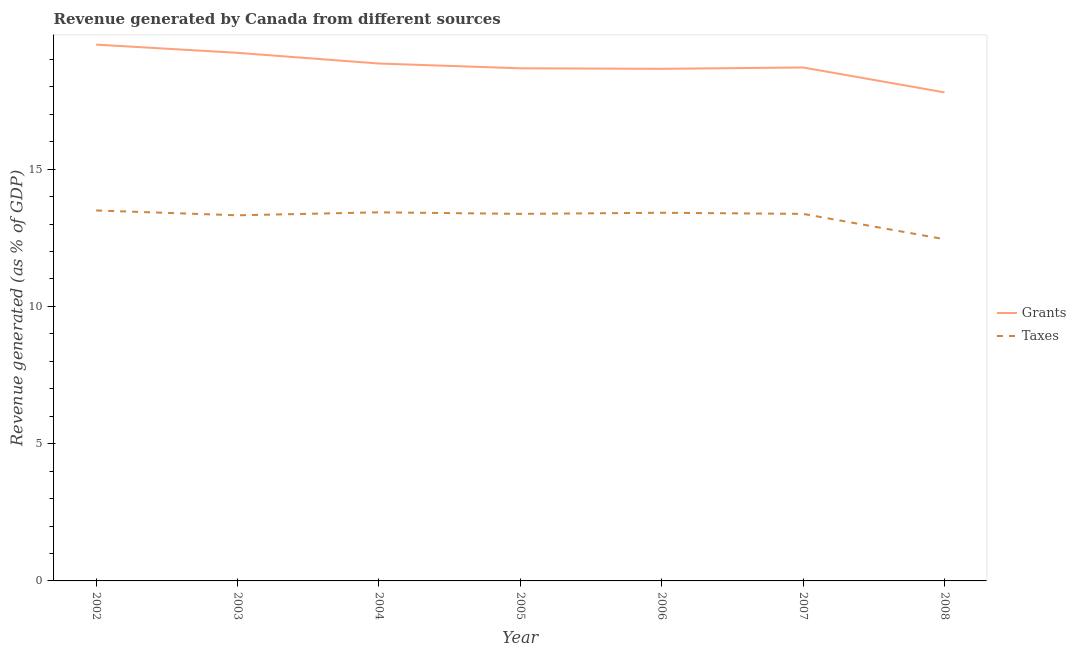Is the number of lines equal to the number of legend labels?
Keep it short and to the point. Yes. What is the revenue generated by grants in 2004?
Your answer should be very brief. 18.85. Across all years, what is the maximum revenue generated by taxes?
Provide a succinct answer. 13.49. Across all years, what is the minimum revenue generated by grants?
Make the answer very short. 17.79. What is the total revenue generated by taxes in the graph?
Your answer should be very brief. 92.83. What is the difference between the revenue generated by taxes in 2007 and that in 2008?
Ensure brevity in your answer.  0.92. What is the difference between the revenue generated by taxes in 2002 and the revenue generated by grants in 2007?
Provide a succinct answer. -5.21. What is the average revenue generated by taxes per year?
Your answer should be compact. 13.26. In the year 2008, what is the difference between the revenue generated by grants and revenue generated by taxes?
Ensure brevity in your answer.  5.35. What is the ratio of the revenue generated by grants in 2003 to that in 2007?
Provide a succinct answer. 1.03. What is the difference between the highest and the second highest revenue generated by taxes?
Make the answer very short. 0.07. What is the difference between the highest and the lowest revenue generated by grants?
Your response must be concise. 1.74. Is the sum of the revenue generated by grants in 2006 and 2007 greater than the maximum revenue generated by taxes across all years?
Provide a succinct answer. Yes. Is the revenue generated by grants strictly greater than the revenue generated by taxes over the years?
Provide a short and direct response. Yes. How many years are there in the graph?
Ensure brevity in your answer.  7. Does the graph contain grids?
Your response must be concise. No. Where does the legend appear in the graph?
Provide a succinct answer. Center right. How are the legend labels stacked?
Your answer should be very brief. Vertical. What is the title of the graph?
Your answer should be very brief. Revenue generated by Canada from different sources. Does "Underweight" appear as one of the legend labels in the graph?
Your answer should be compact. No. What is the label or title of the X-axis?
Ensure brevity in your answer.  Year. What is the label or title of the Y-axis?
Give a very brief answer. Revenue generated (as % of GDP). What is the Revenue generated (as % of GDP) of Grants in 2002?
Offer a terse response. 19.53. What is the Revenue generated (as % of GDP) in Taxes in 2002?
Provide a short and direct response. 13.49. What is the Revenue generated (as % of GDP) of Grants in 2003?
Offer a very short reply. 19.24. What is the Revenue generated (as % of GDP) in Taxes in 2003?
Give a very brief answer. 13.32. What is the Revenue generated (as % of GDP) of Grants in 2004?
Your answer should be compact. 18.85. What is the Revenue generated (as % of GDP) in Taxes in 2004?
Offer a terse response. 13.43. What is the Revenue generated (as % of GDP) in Grants in 2005?
Provide a succinct answer. 18.67. What is the Revenue generated (as % of GDP) in Taxes in 2005?
Make the answer very short. 13.37. What is the Revenue generated (as % of GDP) in Grants in 2006?
Your response must be concise. 18.65. What is the Revenue generated (as % of GDP) in Taxes in 2006?
Ensure brevity in your answer.  13.41. What is the Revenue generated (as % of GDP) in Grants in 2007?
Your answer should be compact. 18.7. What is the Revenue generated (as % of GDP) in Taxes in 2007?
Give a very brief answer. 13.37. What is the Revenue generated (as % of GDP) in Grants in 2008?
Offer a terse response. 17.79. What is the Revenue generated (as % of GDP) of Taxes in 2008?
Give a very brief answer. 12.45. Across all years, what is the maximum Revenue generated (as % of GDP) of Grants?
Keep it short and to the point. 19.53. Across all years, what is the maximum Revenue generated (as % of GDP) of Taxes?
Give a very brief answer. 13.49. Across all years, what is the minimum Revenue generated (as % of GDP) in Grants?
Provide a short and direct response. 17.79. Across all years, what is the minimum Revenue generated (as % of GDP) in Taxes?
Offer a terse response. 12.45. What is the total Revenue generated (as % of GDP) in Grants in the graph?
Your response must be concise. 131.43. What is the total Revenue generated (as % of GDP) in Taxes in the graph?
Offer a very short reply. 92.83. What is the difference between the Revenue generated (as % of GDP) in Grants in 2002 and that in 2003?
Give a very brief answer. 0.3. What is the difference between the Revenue generated (as % of GDP) of Taxes in 2002 and that in 2003?
Offer a very short reply. 0.18. What is the difference between the Revenue generated (as % of GDP) in Grants in 2002 and that in 2004?
Ensure brevity in your answer.  0.69. What is the difference between the Revenue generated (as % of GDP) in Taxes in 2002 and that in 2004?
Your answer should be compact. 0.07. What is the difference between the Revenue generated (as % of GDP) in Grants in 2002 and that in 2005?
Your answer should be compact. 0.86. What is the difference between the Revenue generated (as % of GDP) of Taxes in 2002 and that in 2005?
Give a very brief answer. 0.12. What is the difference between the Revenue generated (as % of GDP) in Grants in 2002 and that in 2006?
Offer a very short reply. 0.88. What is the difference between the Revenue generated (as % of GDP) of Taxes in 2002 and that in 2006?
Keep it short and to the point. 0.08. What is the difference between the Revenue generated (as % of GDP) of Grants in 2002 and that in 2007?
Give a very brief answer. 0.83. What is the difference between the Revenue generated (as % of GDP) in Taxes in 2002 and that in 2007?
Ensure brevity in your answer.  0.12. What is the difference between the Revenue generated (as % of GDP) of Grants in 2002 and that in 2008?
Offer a terse response. 1.74. What is the difference between the Revenue generated (as % of GDP) in Taxes in 2002 and that in 2008?
Provide a short and direct response. 1.05. What is the difference between the Revenue generated (as % of GDP) in Grants in 2003 and that in 2004?
Make the answer very short. 0.39. What is the difference between the Revenue generated (as % of GDP) of Taxes in 2003 and that in 2004?
Offer a very short reply. -0.11. What is the difference between the Revenue generated (as % of GDP) in Grants in 2003 and that in 2005?
Make the answer very short. 0.56. What is the difference between the Revenue generated (as % of GDP) of Taxes in 2003 and that in 2005?
Your response must be concise. -0.05. What is the difference between the Revenue generated (as % of GDP) of Grants in 2003 and that in 2006?
Give a very brief answer. 0.58. What is the difference between the Revenue generated (as % of GDP) in Taxes in 2003 and that in 2006?
Ensure brevity in your answer.  -0.09. What is the difference between the Revenue generated (as % of GDP) in Grants in 2003 and that in 2007?
Offer a very short reply. 0.53. What is the difference between the Revenue generated (as % of GDP) in Taxes in 2003 and that in 2007?
Keep it short and to the point. -0.05. What is the difference between the Revenue generated (as % of GDP) of Grants in 2003 and that in 2008?
Keep it short and to the point. 1.44. What is the difference between the Revenue generated (as % of GDP) in Taxes in 2003 and that in 2008?
Provide a short and direct response. 0.87. What is the difference between the Revenue generated (as % of GDP) of Grants in 2004 and that in 2005?
Your answer should be compact. 0.17. What is the difference between the Revenue generated (as % of GDP) in Taxes in 2004 and that in 2005?
Keep it short and to the point. 0.06. What is the difference between the Revenue generated (as % of GDP) of Grants in 2004 and that in 2006?
Offer a terse response. 0.19. What is the difference between the Revenue generated (as % of GDP) of Taxes in 2004 and that in 2006?
Your response must be concise. 0.02. What is the difference between the Revenue generated (as % of GDP) in Grants in 2004 and that in 2007?
Give a very brief answer. 0.14. What is the difference between the Revenue generated (as % of GDP) of Taxes in 2004 and that in 2007?
Offer a very short reply. 0.06. What is the difference between the Revenue generated (as % of GDP) in Grants in 2004 and that in 2008?
Your response must be concise. 1.05. What is the difference between the Revenue generated (as % of GDP) in Taxes in 2004 and that in 2008?
Offer a very short reply. 0.98. What is the difference between the Revenue generated (as % of GDP) in Grants in 2005 and that in 2006?
Keep it short and to the point. 0.02. What is the difference between the Revenue generated (as % of GDP) in Taxes in 2005 and that in 2006?
Offer a terse response. -0.04. What is the difference between the Revenue generated (as % of GDP) in Grants in 2005 and that in 2007?
Provide a succinct answer. -0.03. What is the difference between the Revenue generated (as % of GDP) of Taxes in 2005 and that in 2007?
Your answer should be compact. 0. What is the difference between the Revenue generated (as % of GDP) in Grants in 2005 and that in 2008?
Provide a short and direct response. 0.88. What is the difference between the Revenue generated (as % of GDP) of Taxes in 2005 and that in 2008?
Offer a terse response. 0.92. What is the difference between the Revenue generated (as % of GDP) in Grants in 2006 and that in 2007?
Make the answer very short. -0.05. What is the difference between the Revenue generated (as % of GDP) of Taxes in 2006 and that in 2007?
Make the answer very short. 0.04. What is the difference between the Revenue generated (as % of GDP) of Grants in 2006 and that in 2008?
Give a very brief answer. 0.86. What is the difference between the Revenue generated (as % of GDP) of Taxes in 2006 and that in 2008?
Keep it short and to the point. 0.96. What is the difference between the Revenue generated (as % of GDP) of Grants in 2007 and that in 2008?
Give a very brief answer. 0.91. What is the difference between the Revenue generated (as % of GDP) in Taxes in 2007 and that in 2008?
Provide a succinct answer. 0.92. What is the difference between the Revenue generated (as % of GDP) in Grants in 2002 and the Revenue generated (as % of GDP) in Taxes in 2003?
Offer a very short reply. 6.22. What is the difference between the Revenue generated (as % of GDP) of Grants in 2002 and the Revenue generated (as % of GDP) of Taxes in 2004?
Provide a succinct answer. 6.11. What is the difference between the Revenue generated (as % of GDP) in Grants in 2002 and the Revenue generated (as % of GDP) in Taxes in 2005?
Provide a succinct answer. 6.17. What is the difference between the Revenue generated (as % of GDP) of Grants in 2002 and the Revenue generated (as % of GDP) of Taxes in 2006?
Make the answer very short. 6.12. What is the difference between the Revenue generated (as % of GDP) in Grants in 2002 and the Revenue generated (as % of GDP) in Taxes in 2007?
Offer a very short reply. 6.17. What is the difference between the Revenue generated (as % of GDP) in Grants in 2002 and the Revenue generated (as % of GDP) in Taxes in 2008?
Provide a short and direct response. 7.09. What is the difference between the Revenue generated (as % of GDP) in Grants in 2003 and the Revenue generated (as % of GDP) in Taxes in 2004?
Keep it short and to the point. 5.81. What is the difference between the Revenue generated (as % of GDP) in Grants in 2003 and the Revenue generated (as % of GDP) in Taxes in 2005?
Provide a succinct answer. 5.87. What is the difference between the Revenue generated (as % of GDP) in Grants in 2003 and the Revenue generated (as % of GDP) in Taxes in 2006?
Provide a short and direct response. 5.83. What is the difference between the Revenue generated (as % of GDP) of Grants in 2003 and the Revenue generated (as % of GDP) of Taxes in 2007?
Offer a terse response. 5.87. What is the difference between the Revenue generated (as % of GDP) in Grants in 2003 and the Revenue generated (as % of GDP) in Taxes in 2008?
Make the answer very short. 6.79. What is the difference between the Revenue generated (as % of GDP) of Grants in 2004 and the Revenue generated (as % of GDP) of Taxes in 2005?
Offer a very short reply. 5.48. What is the difference between the Revenue generated (as % of GDP) in Grants in 2004 and the Revenue generated (as % of GDP) in Taxes in 2006?
Your answer should be very brief. 5.44. What is the difference between the Revenue generated (as % of GDP) of Grants in 2004 and the Revenue generated (as % of GDP) of Taxes in 2007?
Your answer should be compact. 5.48. What is the difference between the Revenue generated (as % of GDP) in Grants in 2004 and the Revenue generated (as % of GDP) in Taxes in 2008?
Make the answer very short. 6.4. What is the difference between the Revenue generated (as % of GDP) in Grants in 2005 and the Revenue generated (as % of GDP) in Taxes in 2006?
Make the answer very short. 5.26. What is the difference between the Revenue generated (as % of GDP) in Grants in 2005 and the Revenue generated (as % of GDP) in Taxes in 2007?
Provide a succinct answer. 5.3. What is the difference between the Revenue generated (as % of GDP) in Grants in 2005 and the Revenue generated (as % of GDP) in Taxes in 2008?
Offer a very short reply. 6.23. What is the difference between the Revenue generated (as % of GDP) in Grants in 2006 and the Revenue generated (as % of GDP) in Taxes in 2007?
Provide a succinct answer. 5.28. What is the difference between the Revenue generated (as % of GDP) of Grants in 2006 and the Revenue generated (as % of GDP) of Taxes in 2008?
Your answer should be very brief. 6.21. What is the difference between the Revenue generated (as % of GDP) in Grants in 2007 and the Revenue generated (as % of GDP) in Taxes in 2008?
Provide a succinct answer. 6.26. What is the average Revenue generated (as % of GDP) in Grants per year?
Give a very brief answer. 18.78. What is the average Revenue generated (as % of GDP) in Taxes per year?
Provide a succinct answer. 13.26. In the year 2002, what is the difference between the Revenue generated (as % of GDP) in Grants and Revenue generated (as % of GDP) in Taxes?
Offer a terse response. 6.04. In the year 2003, what is the difference between the Revenue generated (as % of GDP) of Grants and Revenue generated (as % of GDP) of Taxes?
Give a very brief answer. 5.92. In the year 2004, what is the difference between the Revenue generated (as % of GDP) in Grants and Revenue generated (as % of GDP) in Taxes?
Your answer should be compact. 5.42. In the year 2005, what is the difference between the Revenue generated (as % of GDP) in Grants and Revenue generated (as % of GDP) in Taxes?
Keep it short and to the point. 5.3. In the year 2006, what is the difference between the Revenue generated (as % of GDP) of Grants and Revenue generated (as % of GDP) of Taxes?
Your response must be concise. 5.24. In the year 2007, what is the difference between the Revenue generated (as % of GDP) of Grants and Revenue generated (as % of GDP) of Taxes?
Keep it short and to the point. 5.33. In the year 2008, what is the difference between the Revenue generated (as % of GDP) in Grants and Revenue generated (as % of GDP) in Taxes?
Your response must be concise. 5.35. What is the ratio of the Revenue generated (as % of GDP) in Grants in 2002 to that in 2003?
Make the answer very short. 1.02. What is the ratio of the Revenue generated (as % of GDP) of Taxes in 2002 to that in 2003?
Offer a terse response. 1.01. What is the ratio of the Revenue generated (as % of GDP) of Grants in 2002 to that in 2004?
Keep it short and to the point. 1.04. What is the ratio of the Revenue generated (as % of GDP) of Taxes in 2002 to that in 2004?
Your answer should be compact. 1.01. What is the ratio of the Revenue generated (as % of GDP) of Grants in 2002 to that in 2005?
Keep it short and to the point. 1.05. What is the ratio of the Revenue generated (as % of GDP) of Taxes in 2002 to that in 2005?
Your answer should be compact. 1.01. What is the ratio of the Revenue generated (as % of GDP) of Grants in 2002 to that in 2006?
Offer a terse response. 1.05. What is the ratio of the Revenue generated (as % of GDP) of Grants in 2002 to that in 2007?
Offer a terse response. 1.04. What is the ratio of the Revenue generated (as % of GDP) of Taxes in 2002 to that in 2007?
Ensure brevity in your answer.  1.01. What is the ratio of the Revenue generated (as % of GDP) of Grants in 2002 to that in 2008?
Provide a short and direct response. 1.1. What is the ratio of the Revenue generated (as % of GDP) of Taxes in 2002 to that in 2008?
Provide a succinct answer. 1.08. What is the ratio of the Revenue generated (as % of GDP) of Grants in 2003 to that in 2004?
Provide a succinct answer. 1.02. What is the ratio of the Revenue generated (as % of GDP) of Taxes in 2003 to that in 2004?
Keep it short and to the point. 0.99. What is the ratio of the Revenue generated (as % of GDP) in Grants in 2003 to that in 2005?
Make the answer very short. 1.03. What is the ratio of the Revenue generated (as % of GDP) of Taxes in 2003 to that in 2005?
Provide a short and direct response. 1. What is the ratio of the Revenue generated (as % of GDP) of Grants in 2003 to that in 2006?
Offer a terse response. 1.03. What is the ratio of the Revenue generated (as % of GDP) of Grants in 2003 to that in 2007?
Provide a succinct answer. 1.03. What is the ratio of the Revenue generated (as % of GDP) of Taxes in 2003 to that in 2007?
Give a very brief answer. 1. What is the ratio of the Revenue generated (as % of GDP) of Grants in 2003 to that in 2008?
Provide a short and direct response. 1.08. What is the ratio of the Revenue generated (as % of GDP) of Taxes in 2003 to that in 2008?
Provide a succinct answer. 1.07. What is the ratio of the Revenue generated (as % of GDP) of Grants in 2004 to that in 2005?
Your answer should be compact. 1.01. What is the ratio of the Revenue generated (as % of GDP) in Grants in 2004 to that in 2006?
Provide a succinct answer. 1.01. What is the ratio of the Revenue generated (as % of GDP) in Taxes in 2004 to that in 2006?
Your response must be concise. 1. What is the ratio of the Revenue generated (as % of GDP) in Grants in 2004 to that in 2007?
Your answer should be very brief. 1.01. What is the ratio of the Revenue generated (as % of GDP) in Grants in 2004 to that in 2008?
Your answer should be compact. 1.06. What is the ratio of the Revenue generated (as % of GDP) in Taxes in 2004 to that in 2008?
Keep it short and to the point. 1.08. What is the ratio of the Revenue generated (as % of GDP) in Grants in 2005 to that in 2006?
Provide a succinct answer. 1. What is the ratio of the Revenue generated (as % of GDP) of Grants in 2005 to that in 2008?
Offer a very short reply. 1.05. What is the ratio of the Revenue generated (as % of GDP) in Taxes in 2005 to that in 2008?
Your answer should be very brief. 1.07. What is the ratio of the Revenue generated (as % of GDP) in Grants in 2006 to that in 2007?
Provide a short and direct response. 1. What is the ratio of the Revenue generated (as % of GDP) in Grants in 2006 to that in 2008?
Offer a very short reply. 1.05. What is the ratio of the Revenue generated (as % of GDP) of Taxes in 2006 to that in 2008?
Give a very brief answer. 1.08. What is the ratio of the Revenue generated (as % of GDP) of Grants in 2007 to that in 2008?
Give a very brief answer. 1.05. What is the ratio of the Revenue generated (as % of GDP) of Taxes in 2007 to that in 2008?
Give a very brief answer. 1.07. What is the difference between the highest and the second highest Revenue generated (as % of GDP) of Grants?
Give a very brief answer. 0.3. What is the difference between the highest and the second highest Revenue generated (as % of GDP) of Taxes?
Provide a short and direct response. 0.07. What is the difference between the highest and the lowest Revenue generated (as % of GDP) of Grants?
Keep it short and to the point. 1.74. What is the difference between the highest and the lowest Revenue generated (as % of GDP) of Taxes?
Your answer should be very brief. 1.05. 